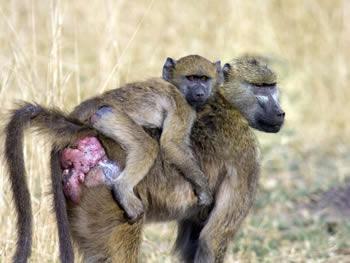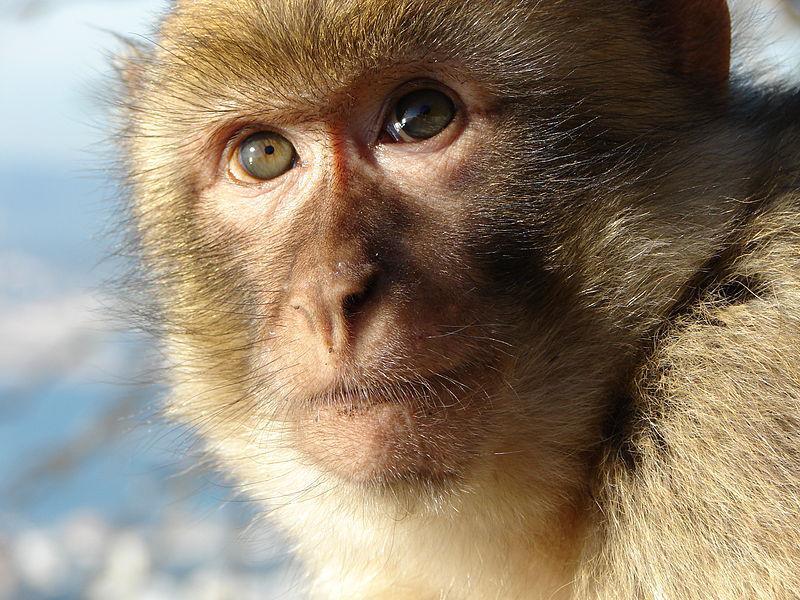The first image is the image on the left, the second image is the image on the right. Assess this claim about the two images: "A baboon is standing on all fours with its tail and pink rear angled toward the camera and its head turned.". Correct or not? Answer yes or no. Yes. The first image is the image on the left, the second image is the image on the right. Examine the images to the left and right. Is the description "The left image contains exactly two baboons." accurate? Answer yes or no. Yes. 